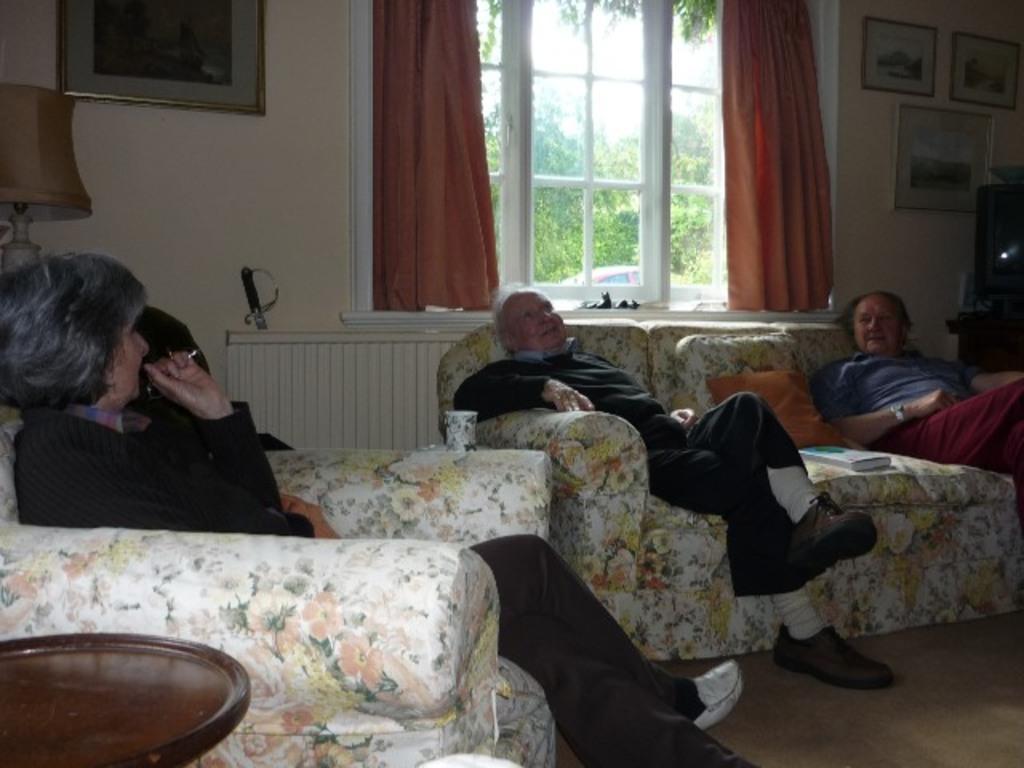How would you summarize this image in a sentence or two? There are three people sitting in a sofa. There are two men sitting together on the same sofa. Behind them there is a window with the orange color curtains to it. To the right side top corner there are three frames. And one tv. To the left side corner there is a lamp and on the wall there is a frame. 